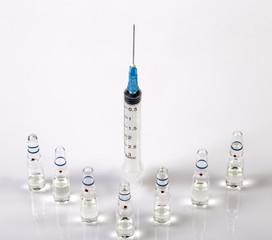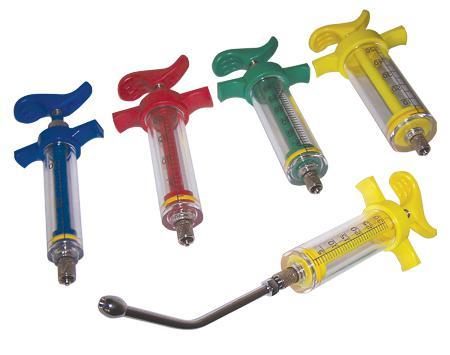The first image is the image on the left, the second image is the image on the right. Examine the images to the left and right. Is the description "Three syringes lie on a surface near each other in the image on the left." accurate? Answer yes or no. No. The first image is the image on the left, the second image is the image on the right. Given the left and right images, does the statement "An image includes syringes with green, red, and blue components." hold true? Answer yes or no. Yes. 